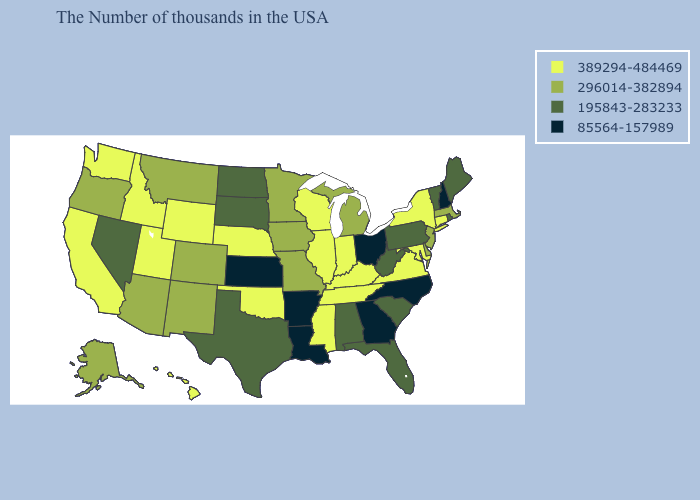What is the value of Illinois?
Quick response, please. 389294-484469. Does Hawaii have a lower value than New Mexico?
Keep it brief. No. What is the value of Mississippi?
Give a very brief answer. 389294-484469. What is the value of South Dakota?
Be succinct. 195843-283233. Name the states that have a value in the range 85564-157989?
Write a very short answer. New Hampshire, North Carolina, Ohio, Georgia, Louisiana, Arkansas, Kansas. What is the value of Pennsylvania?
Keep it brief. 195843-283233. Does North Carolina have a higher value than Florida?
Give a very brief answer. No. Among the states that border Wisconsin , does Illinois have the highest value?
Concise answer only. Yes. Name the states that have a value in the range 195843-283233?
Write a very short answer. Maine, Rhode Island, Vermont, Pennsylvania, South Carolina, West Virginia, Florida, Alabama, Texas, South Dakota, North Dakota, Nevada. Which states hav the highest value in the West?
Quick response, please. Wyoming, Utah, Idaho, California, Washington, Hawaii. Among the states that border Indiana , which have the lowest value?
Answer briefly. Ohio. Does Georgia have the lowest value in the South?
Be succinct. Yes. Among the states that border North Carolina , does Virginia have the highest value?
Write a very short answer. Yes. Does Arizona have a higher value than Minnesota?
Answer briefly. No. Which states have the lowest value in the Northeast?
Concise answer only. New Hampshire. 